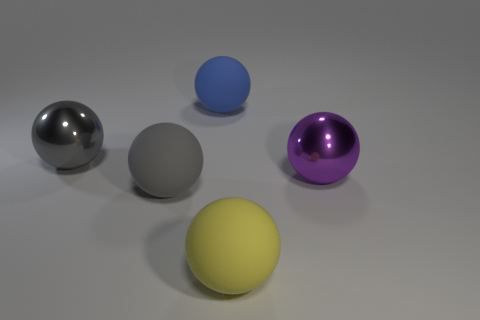Is the number of big matte objects in front of the large gray rubber thing greater than the number of shiny spheres to the left of the gray metallic thing?
Your answer should be very brief. Yes. How many large red objects are made of the same material as the big blue ball?
Offer a very short reply. 0. What number of things are large purple shiny things or small blue cubes?
Provide a succinct answer. 1. Are there any blue objects that have the same shape as the yellow rubber thing?
Provide a succinct answer. Yes. The matte object to the left of the big rubber thing that is behind the large gray metallic ball is what shape?
Your answer should be very brief. Sphere. Are there any yellow rubber objects of the same size as the purple shiny ball?
Your answer should be compact. Yes. Is the number of large gray spheres less than the number of yellow balls?
Your answer should be compact. No. What number of objects are big yellow balls that are in front of the big purple thing or objects that are in front of the gray matte ball?
Offer a very short reply. 1. There is a blue rubber object; are there any rubber balls on the right side of it?
Your answer should be compact. Yes. How many objects are big metallic balls in front of the large gray shiny sphere or large spheres?
Offer a very short reply. 5. 